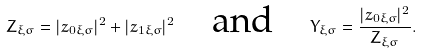<formula> <loc_0><loc_0><loc_500><loc_500>Z _ { \xi \sigma } = | z _ { 0 \xi \sigma } | ^ { 2 } + | z _ { 1 \xi \sigma } | ^ { 2 } \quad \text {and} \quad Y _ { \xi \sigma } = \frac { | z _ { 0 \xi \sigma } | ^ { 2 } } { Z _ { \xi \sigma } } .</formula> 